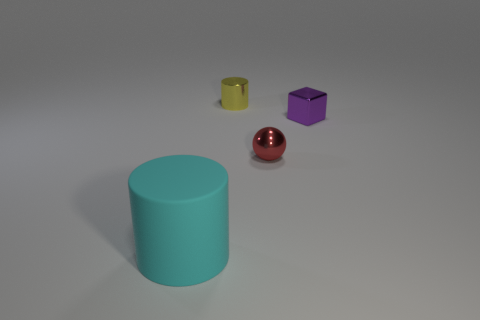What is the material of the red thing that is the same size as the block?
Make the answer very short. Metal. How many things are either cylinders left of the small yellow shiny object or metal cylinders?
Your answer should be compact. 2. Are any large objects visible?
Keep it short and to the point. Yes. What material is the cylinder that is in front of the tiny yellow object?
Ensure brevity in your answer.  Rubber. What number of big things are yellow metal cylinders or brown metallic blocks?
Your response must be concise. 0. The large thing has what color?
Make the answer very short. Cyan. There is a cylinder that is in front of the yellow metal object; is there a tiny thing in front of it?
Your answer should be compact. No. Is the number of tiny metal things right of the red metal thing less than the number of big yellow metal objects?
Ensure brevity in your answer.  No. Are the cylinder that is in front of the yellow cylinder and the small yellow cylinder made of the same material?
Offer a very short reply. No. What is the color of the cylinder that is the same material as the small purple object?
Offer a terse response. Yellow. 